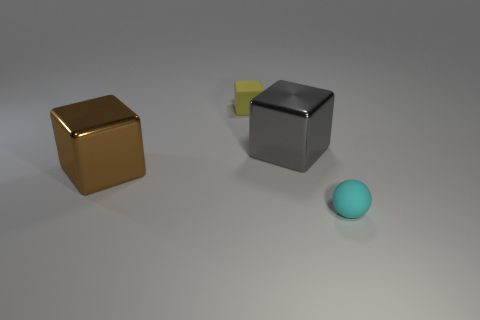Is the number of cubes on the left side of the gray object less than the number of cubes?
Provide a succinct answer. Yes. What number of yellow rubber cylinders are there?
Offer a very short reply. 0. Is the shape of the tiny cyan object the same as the big metallic thing that is to the right of the small yellow matte object?
Offer a very short reply. No. Are there fewer big things right of the tiny ball than large gray metal cubes that are behind the large gray metallic cube?
Keep it short and to the point. No. Is there any other thing that is the same shape as the cyan matte thing?
Your response must be concise. No. Do the gray object and the small cyan rubber object have the same shape?
Keep it short and to the point. No. The brown block is what size?
Offer a terse response. Large. What color is the object that is both to the right of the tiny block and behind the cyan rubber thing?
Provide a succinct answer. Gray. Is the number of gray blocks greater than the number of large brown rubber cubes?
Provide a succinct answer. Yes. What number of objects are either tiny yellow rubber objects or things that are to the left of the cyan matte ball?
Offer a very short reply. 3. 